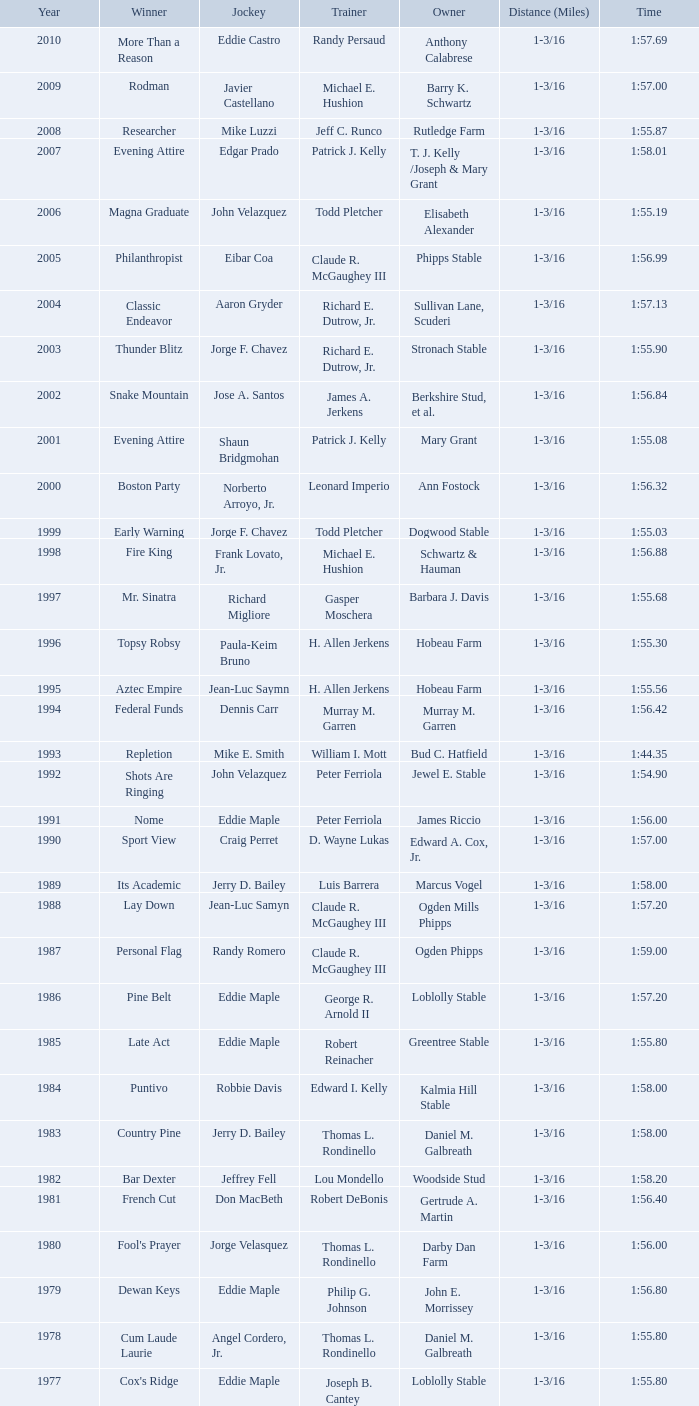In a year post-1909, when there was no winner, how long was the race? 1 mile, 1 mile, 1 mile. 